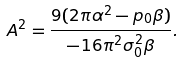Convert formula to latex. <formula><loc_0><loc_0><loc_500><loc_500>A ^ { 2 } = \frac { 9 ( 2 \pi \alpha ^ { 2 } - p _ { 0 } \beta ) } { - 1 6 \pi ^ { 2 } \sigma _ { 0 } ^ { 2 } \beta } .</formula> 